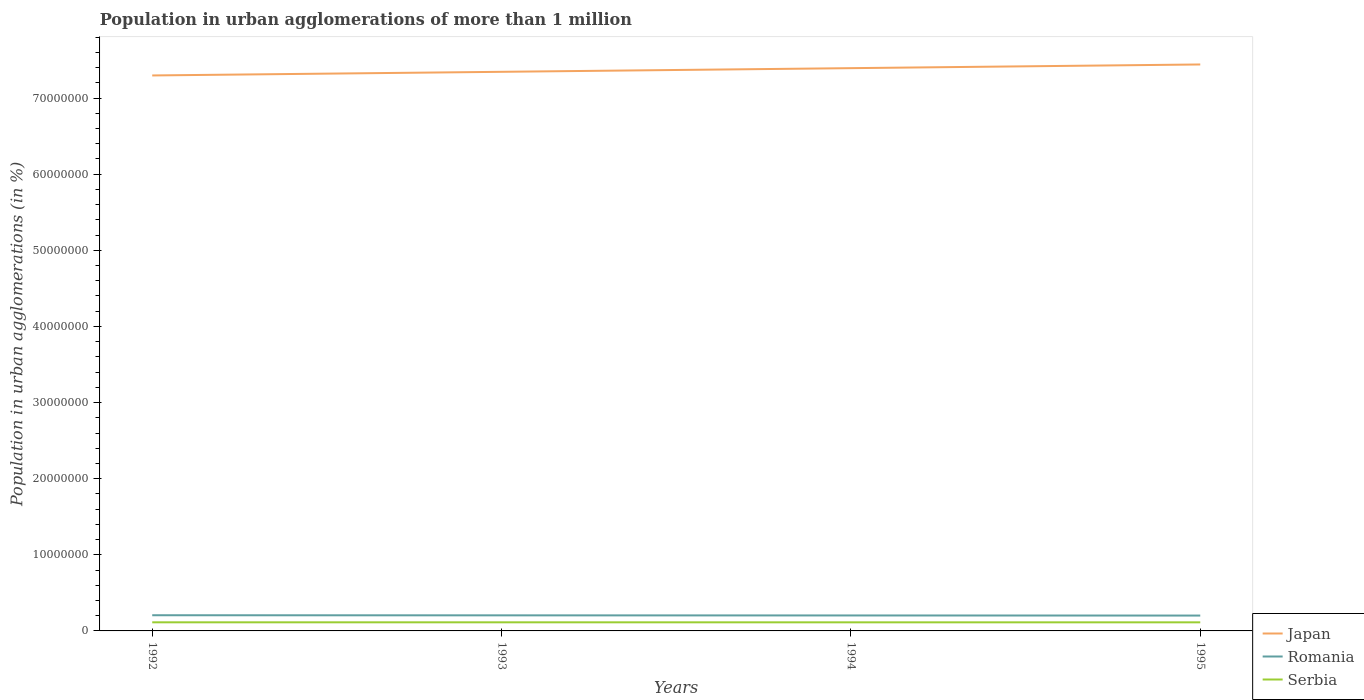Across all years, what is the maximum population in urban agglomerations in Japan?
Your answer should be compact. 7.30e+07. What is the total population in urban agglomerations in Romania in the graph?
Keep it short and to the point. 4.24e+04. What is the difference between the highest and the second highest population in urban agglomerations in Japan?
Your answer should be very brief. 1.44e+06. Is the population in urban agglomerations in Japan strictly greater than the population in urban agglomerations in Romania over the years?
Keep it short and to the point. No. How many lines are there?
Make the answer very short. 3. How many years are there in the graph?
Offer a very short reply. 4. Are the values on the major ticks of Y-axis written in scientific E-notation?
Give a very brief answer. No. How many legend labels are there?
Offer a very short reply. 3. What is the title of the graph?
Your response must be concise. Population in urban agglomerations of more than 1 million. Does "Puerto Rico" appear as one of the legend labels in the graph?
Provide a succinct answer. No. What is the label or title of the Y-axis?
Keep it short and to the point. Population in urban agglomerations (in %). What is the Population in urban agglomerations (in %) of Japan in 1992?
Make the answer very short. 7.30e+07. What is the Population in urban agglomerations (in %) in Romania in 1992?
Provide a short and direct response. 2.06e+06. What is the Population in urban agglomerations (in %) in Serbia in 1992?
Make the answer very short. 1.13e+06. What is the Population in urban agglomerations (in %) in Japan in 1993?
Provide a succinct answer. 7.34e+07. What is the Population in urban agglomerations (in %) in Romania in 1993?
Ensure brevity in your answer.  2.05e+06. What is the Population in urban agglomerations (in %) of Serbia in 1993?
Give a very brief answer. 1.13e+06. What is the Population in urban agglomerations (in %) in Japan in 1994?
Ensure brevity in your answer.  7.39e+07. What is the Population in urban agglomerations (in %) of Romania in 1994?
Give a very brief answer. 2.03e+06. What is the Population in urban agglomerations (in %) in Serbia in 1994?
Your answer should be compact. 1.13e+06. What is the Population in urban agglomerations (in %) in Japan in 1995?
Provide a short and direct response. 7.44e+07. What is the Population in urban agglomerations (in %) of Romania in 1995?
Give a very brief answer. 2.02e+06. What is the Population in urban agglomerations (in %) in Serbia in 1995?
Give a very brief answer. 1.13e+06. Across all years, what is the maximum Population in urban agglomerations (in %) in Japan?
Give a very brief answer. 7.44e+07. Across all years, what is the maximum Population in urban agglomerations (in %) in Romania?
Keep it short and to the point. 2.06e+06. Across all years, what is the maximum Population in urban agglomerations (in %) in Serbia?
Keep it short and to the point. 1.13e+06. Across all years, what is the minimum Population in urban agglomerations (in %) in Japan?
Give a very brief answer. 7.30e+07. Across all years, what is the minimum Population in urban agglomerations (in %) of Romania?
Keep it short and to the point. 2.02e+06. Across all years, what is the minimum Population in urban agglomerations (in %) in Serbia?
Your answer should be compact. 1.13e+06. What is the total Population in urban agglomerations (in %) in Japan in the graph?
Provide a succinct answer. 2.95e+08. What is the total Population in urban agglomerations (in %) of Romania in the graph?
Your response must be concise. 8.16e+06. What is the total Population in urban agglomerations (in %) in Serbia in the graph?
Provide a short and direct response. 4.52e+06. What is the difference between the Population in urban agglomerations (in %) of Japan in 1992 and that in 1993?
Offer a very short reply. -4.77e+05. What is the difference between the Population in urban agglomerations (in %) of Romania in 1992 and that in 1993?
Make the answer very short. 1.42e+04. What is the difference between the Population in urban agglomerations (in %) in Serbia in 1992 and that in 1993?
Offer a very short reply. 1230. What is the difference between the Population in urban agglomerations (in %) in Japan in 1992 and that in 1994?
Offer a terse response. -9.58e+05. What is the difference between the Population in urban agglomerations (in %) of Romania in 1992 and that in 1994?
Your response must be concise. 2.84e+04. What is the difference between the Population in urban agglomerations (in %) in Serbia in 1992 and that in 1994?
Provide a short and direct response. 2461. What is the difference between the Population in urban agglomerations (in %) of Japan in 1992 and that in 1995?
Your answer should be very brief. -1.44e+06. What is the difference between the Population in urban agglomerations (in %) of Romania in 1992 and that in 1995?
Offer a very short reply. 4.24e+04. What is the difference between the Population in urban agglomerations (in %) of Serbia in 1992 and that in 1995?
Make the answer very short. 3691. What is the difference between the Population in urban agglomerations (in %) of Japan in 1993 and that in 1994?
Your answer should be compact. -4.81e+05. What is the difference between the Population in urban agglomerations (in %) of Romania in 1993 and that in 1994?
Your response must be concise. 1.42e+04. What is the difference between the Population in urban agglomerations (in %) in Serbia in 1993 and that in 1994?
Give a very brief answer. 1231. What is the difference between the Population in urban agglomerations (in %) of Japan in 1993 and that in 1995?
Offer a very short reply. -9.65e+05. What is the difference between the Population in urban agglomerations (in %) in Romania in 1993 and that in 1995?
Offer a very short reply. 2.82e+04. What is the difference between the Population in urban agglomerations (in %) of Serbia in 1993 and that in 1995?
Your answer should be very brief. 2461. What is the difference between the Population in urban agglomerations (in %) in Japan in 1994 and that in 1995?
Your answer should be compact. -4.84e+05. What is the difference between the Population in urban agglomerations (in %) of Romania in 1994 and that in 1995?
Make the answer very short. 1.41e+04. What is the difference between the Population in urban agglomerations (in %) in Serbia in 1994 and that in 1995?
Provide a succinct answer. 1230. What is the difference between the Population in urban agglomerations (in %) in Japan in 1992 and the Population in urban agglomerations (in %) in Romania in 1993?
Ensure brevity in your answer.  7.09e+07. What is the difference between the Population in urban agglomerations (in %) in Japan in 1992 and the Population in urban agglomerations (in %) in Serbia in 1993?
Provide a short and direct response. 7.18e+07. What is the difference between the Population in urban agglomerations (in %) of Romania in 1992 and the Population in urban agglomerations (in %) of Serbia in 1993?
Your answer should be very brief. 9.30e+05. What is the difference between the Population in urban agglomerations (in %) of Japan in 1992 and the Population in urban agglomerations (in %) of Romania in 1994?
Keep it short and to the point. 7.09e+07. What is the difference between the Population in urban agglomerations (in %) in Japan in 1992 and the Population in urban agglomerations (in %) in Serbia in 1994?
Provide a succinct answer. 7.18e+07. What is the difference between the Population in urban agglomerations (in %) in Romania in 1992 and the Population in urban agglomerations (in %) in Serbia in 1994?
Give a very brief answer. 9.32e+05. What is the difference between the Population in urban agglomerations (in %) in Japan in 1992 and the Population in urban agglomerations (in %) in Romania in 1995?
Keep it short and to the point. 7.10e+07. What is the difference between the Population in urban agglomerations (in %) in Japan in 1992 and the Population in urban agglomerations (in %) in Serbia in 1995?
Offer a very short reply. 7.18e+07. What is the difference between the Population in urban agglomerations (in %) of Romania in 1992 and the Population in urban agglomerations (in %) of Serbia in 1995?
Make the answer very short. 9.33e+05. What is the difference between the Population in urban agglomerations (in %) of Japan in 1993 and the Population in urban agglomerations (in %) of Romania in 1994?
Keep it short and to the point. 7.14e+07. What is the difference between the Population in urban agglomerations (in %) in Japan in 1993 and the Population in urban agglomerations (in %) in Serbia in 1994?
Your answer should be very brief. 7.23e+07. What is the difference between the Population in urban agglomerations (in %) of Romania in 1993 and the Population in urban agglomerations (in %) of Serbia in 1994?
Your answer should be very brief. 9.17e+05. What is the difference between the Population in urban agglomerations (in %) in Japan in 1993 and the Population in urban agglomerations (in %) in Romania in 1995?
Ensure brevity in your answer.  7.14e+07. What is the difference between the Population in urban agglomerations (in %) in Japan in 1993 and the Population in urban agglomerations (in %) in Serbia in 1995?
Keep it short and to the point. 7.23e+07. What is the difference between the Population in urban agglomerations (in %) in Romania in 1993 and the Population in urban agglomerations (in %) in Serbia in 1995?
Your response must be concise. 9.19e+05. What is the difference between the Population in urban agglomerations (in %) in Japan in 1994 and the Population in urban agglomerations (in %) in Romania in 1995?
Provide a short and direct response. 7.19e+07. What is the difference between the Population in urban agglomerations (in %) in Japan in 1994 and the Population in urban agglomerations (in %) in Serbia in 1995?
Offer a terse response. 7.28e+07. What is the difference between the Population in urban agglomerations (in %) of Romania in 1994 and the Population in urban agglomerations (in %) of Serbia in 1995?
Offer a terse response. 9.04e+05. What is the average Population in urban agglomerations (in %) of Japan per year?
Provide a short and direct response. 7.37e+07. What is the average Population in urban agglomerations (in %) in Romania per year?
Ensure brevity in your answer.  2.04e+06. What is the average Population in urban agglomerations (in %) of Serbia per year?
Your answer should be compact. 1.13e+06. In the year 1992, what is the difference between the Population in urban agglomerations (in %) in Japan and Population in urban agglomerations (in %) in Romania?
Ensure brevity in your answer.  7.09e+07. In the year 1992, what is the difference between the Population in urban agglomerations (in %) of Japan and Population in urban agglomerations (in %) of Serbia?
Make the answer very short. 7.18e+07. In the year 1992, what is the difference between the Population in urban agglomerations (in %) of Romania and Population in urban agglomerations (in %) of Serbia?
Offer a terse response. 9.29e+05. In the year 1993, what is the difference between the Population in urban agglomerations (in %) in Japan and Population in urban agglomerations (in %) in Romania?
Offer a terse response. 7.14e+07. In the year 1993, what is the difference between the Population in urban agglomerations (in %) in Japan and Population in urban agglomerations (in %) in Serbia?
Give a very brief answer. 7.23e+07. In the year 1993, what is the difference between the Population in urban agglomerations (in %) of Romania and Population in urban agglomerations (in %) of Serbia?
Offer a terse response. 9.16e+05. In the year 1994, what is the difference between the Population in urban agglomerations (in %) in Japan and Population in urban agglomerations (in %) in Romania?
Make the answer very short. 7.19e+07. In the year 1994, what is the difference between the Population in urban agglomerations (in %) in Japan and Population in urban agglomerations (in %) in Serbia?
Your response must be concise. 7.28e+07. In the year 1994, what is the difference between the Population in urban agglomerations (in %) in Romania and Population in urban agglomerations (in %) in Serbia?
Ensure brevity in your answer.  9.03e+05. In the year 1995, what is the difference between the Population in urban agglomerations (in %) in Japan and Population in urban agglomerations (in %) in Romania?
Make the answer very short. 7.24e+07. In the year 1995, what is the difference between the Population in urban agglomerations (in %) of Japan and Population in urban agglomerations (in %) of Serbia?
Give a very brief answer. 7.33e+07. In the year 1995, what is the difference between the Population in urban agglomerations (in %) of Romania and Population in urban agglomerations (in %) of Serbia?
Offer a terse response. 8.90e+05. What is the ratio of the Population in urban agglomerations (in %) in Serbia in 1992 to that in 1994?
Ensure brevity in your answer.  1. What is the ratio of the Population in urban agglomerations (in %) in Japan in 1992 to that in 1995?
Offer a very short reply. 0.98. What is the ratio of the Population in urban agglomerations (in %) in Romania in 1993 to that in 1994?
Offer a terse response. 1.01. What is the ratio of the Population in urban agglomerations (in %) in Serbia in 1993 to that in 1994?
Give a very brief answer. 1. What is the ratio of the Population in urban agglomerations (in %) of Japan in 1993 to that in 1995?
Keep it short and to the point. 0.99. What is the ratio of the Population in urban agglomerations (in %) in Japan in 1994 to that in 1995?
Provide a short and direct response. 0.99. What is the ratio of the Population in urban agglomerations (in %) in Serbia in 1994 to that in 1995?
Ensure brevity in your answer.  1. What is the difference between the highest and the second highest Population in urban agglomerations (in %) in Japan?
Provide a short and direct response. 4.84e+05. What is the difference between the highest and the second highest Population in urban agglomerations (in %) in Romania?
Ensure brevity in your answer.  1.42e+04. What is the difference between the highest and the second highest Population in urban agglomerations (in %) of Serbia?
Your response must be concise. 1230. What is the difference between the highest and the lowest Population in urban agglomerations (in %) of Japan?
Provide a short and direct response. 1.44e+06. What is the difference between the highest and the lowest Population in urban agglomerations (in %) in Romania?
Ensure brevity in your answer.  4.24e+04. What is the difference between the highest and the lowest Population in urban agglomerations (in %) in Serbia?
Your answer should be compact. 3691. 